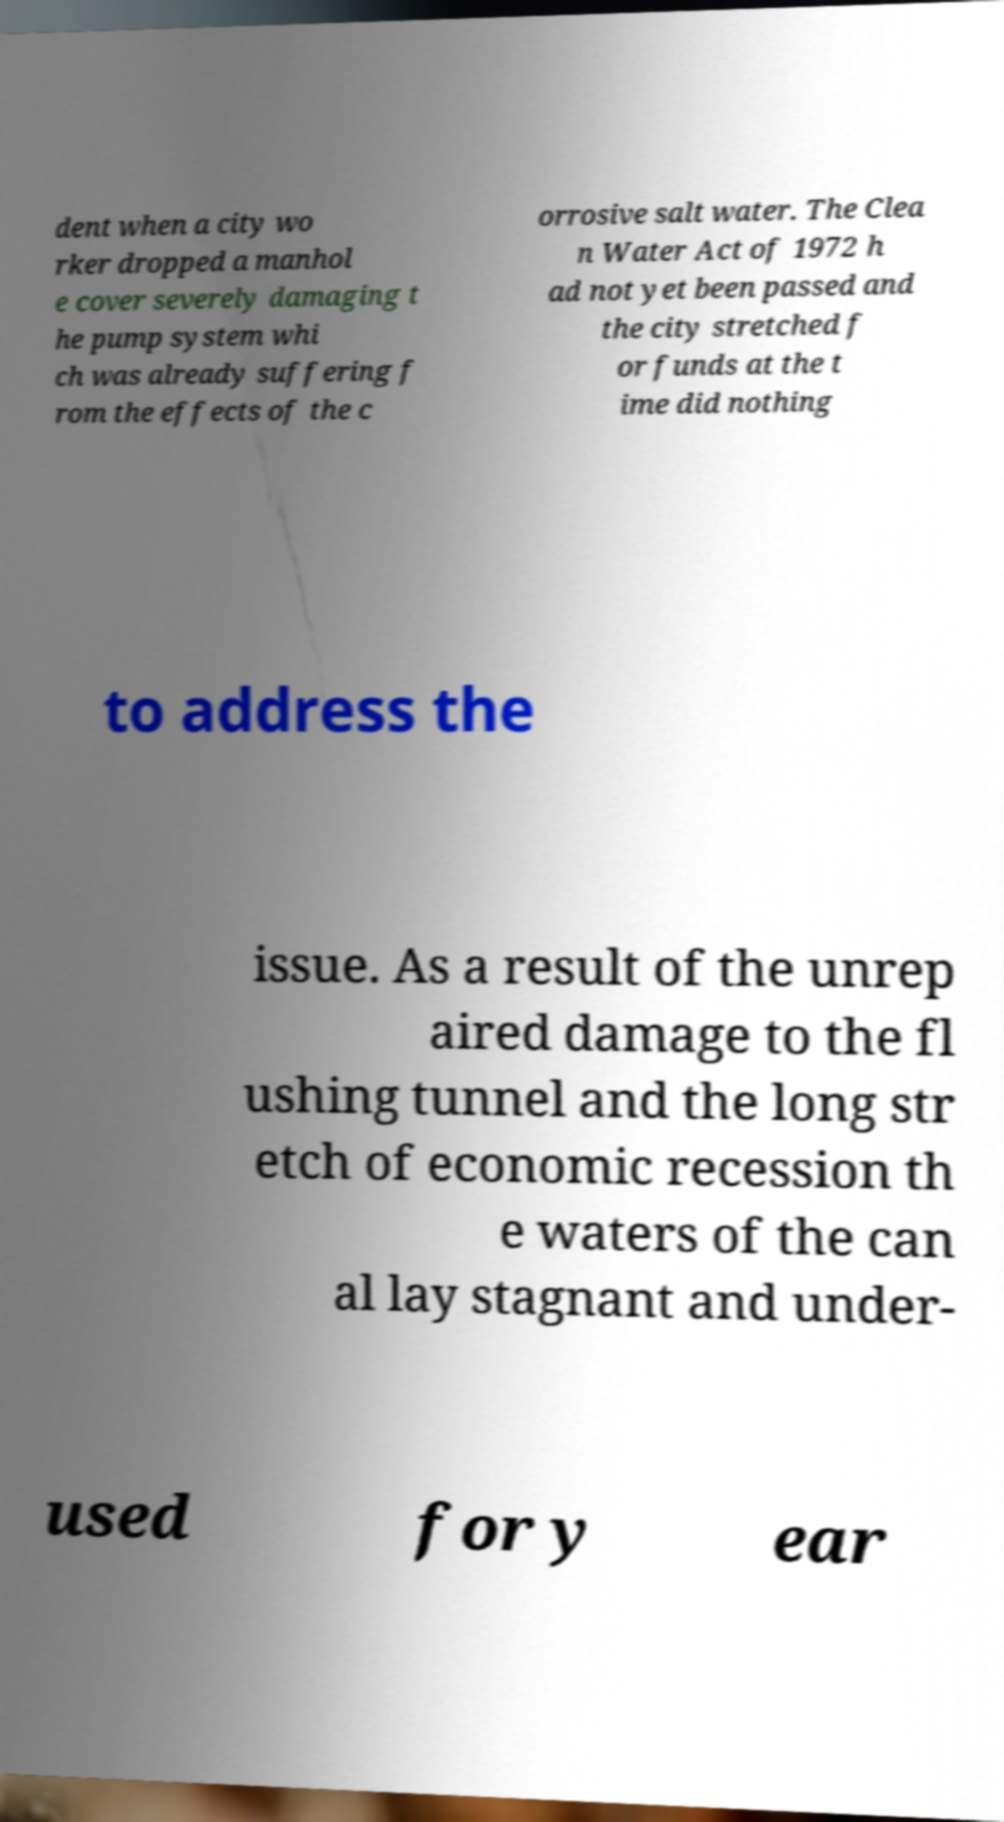I need the written content from this picture converted into text. Can you do that? dent when a city wo rker dropped a manhol e cover severely damaging t he pump system whi ch was already suffering f rom the effects of the c orrosive salt water. The Clea n Water Act of 1972 h ad not yet been passed and the city stretched f or funds at the t ime did nothing to address the issue. As a result of the unrep aired damage to the fl ushing tunnel and the long str etch of economic recession th e waters of the can al lay stagnant and under- used for y ear 